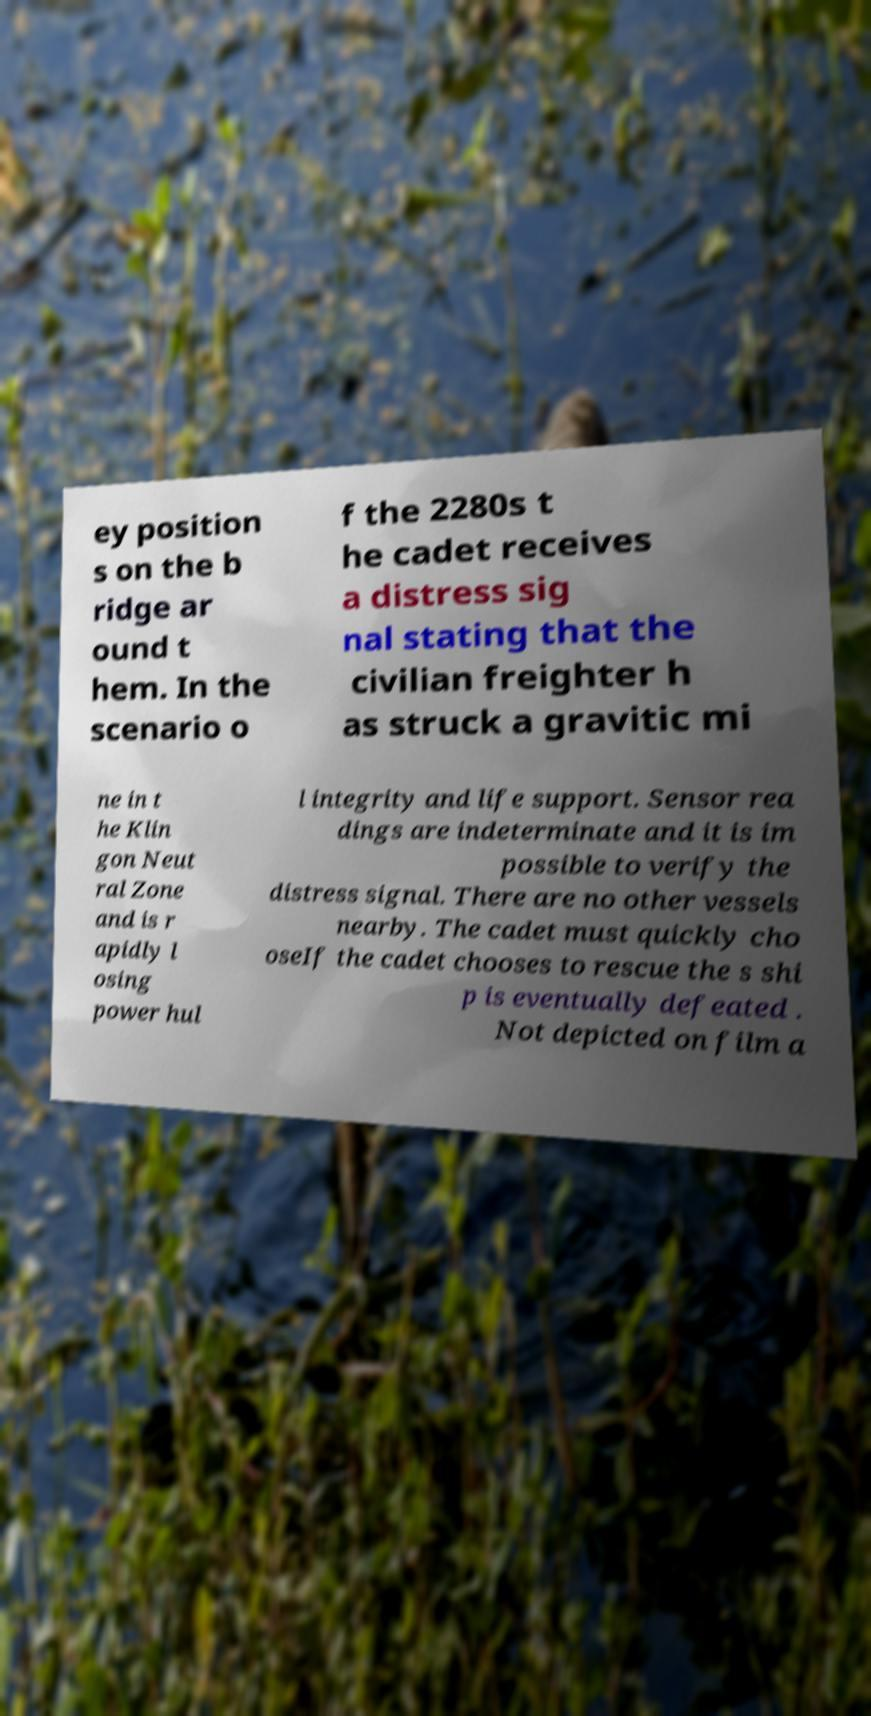What messages or text are displayed in this image? I need them in a readable, typed format. ey position s on the b ridge ar ound t hem. In the scenario o f the 2280s t he cadet receives a distress sig nal stating that the civilian freighter h as struck a gravitic mi ne in t he Klin gon Neut ral Zone and is r apidly l osing power hul l integrity and life support. Sensor rea dings are indeterminate and it is im possible to verify the distress signal. There are no other vessels nearby. The cadet must quickly cho oseIf the cadet chooses to rescue the s shi p is eventually defeated . Not depicted on film a 